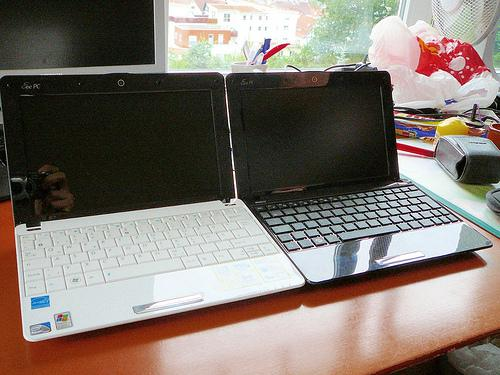Question: how many laptops are there?
Choices:
A. One.
B. Three.
C. Two.
D. Four.
Answer with the letter. Answer: C Question: what color are the laptops?
Choices:
A. Gray.
B. Black and white.
C. Silver.
D. Black.
Answer with the letter. Answer: B Question: what are the laptops on?
Choices:
A. The desk.
B. The floor.
C. The ground.
D. The table.
Answer with the letter. Answer: D Question: what is the table made of?
Choices:
A. Plastic.
B. Metal.
C. Wood.
D. Stone.
Answer with the letter. Answer: C Question: what is on the table?
Choices:
A. Plates.
B. Candles.
C. The laptops.
D. Food.
Answer with the letter. Answer: C 